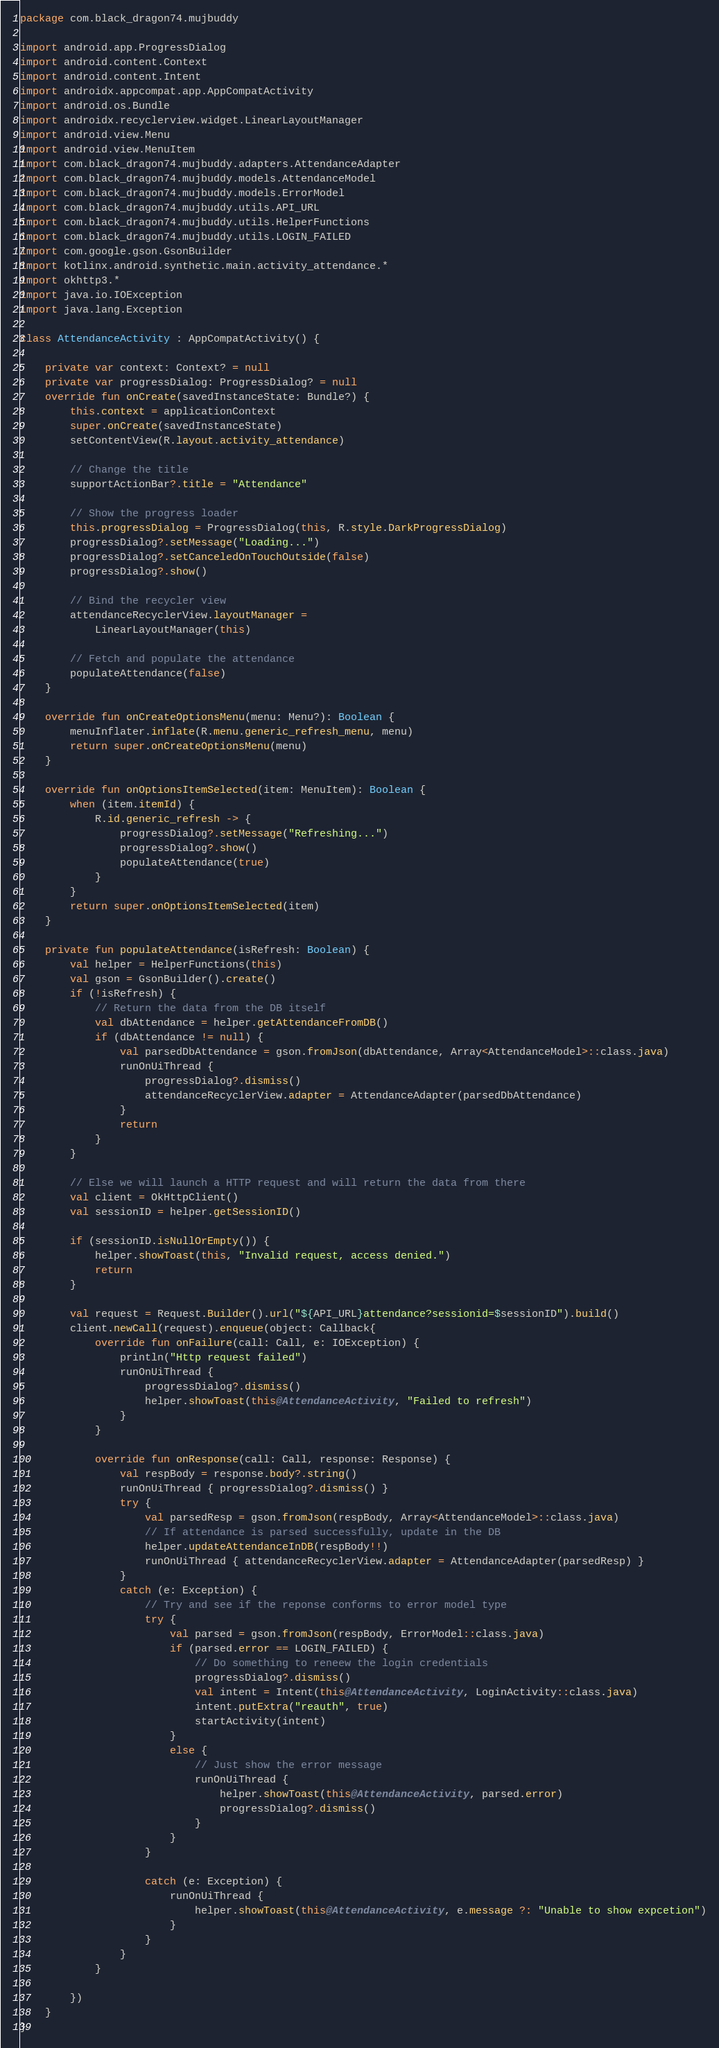<code> <loc_0><loc_0><loc_500><loc_500><_Kotlin_>package com.black_dragon74.mujbuddy

import android.app.ProgressDialog
import android.content.Context
import android.content.Intent
import androidx.appcompat.app.AppCompatActivity
import android.os.Bundle
import androidx.recyclerview.widget.LinearLayoutManager
import android.view.Menu
import android.view.MenuItem
import com.black_dragon74.mujbuddy.adapters.AttendanceAdapter
import com.black_dragon74.mujbuddy.models.AttendanceModel
import com.black_dragon74.mujbuddy.models.ErrorModel
import com.black_dragon74.mujbuddy.utils.API_URL
import com.black_dragon74.mujbuddy.utils.HelperFunctions
import com.black_dragon74.mujbuddy.utils.LOGIN_FAILED
import com.google.gson.GsonBuilder
import kotlinx.android.synthetic.main.activity_attendance.*
import okhttp3.*
import java.io.IOException
import java.lang.Exception

class AttendanceActivity : AppCompatActivity() {

    private var context: Context? = null
    private var progressDialog: ProgressDialog? = null
    override fun onCreate(savedInstanceState: Bundle?) {
        this.context = applicationContext
        super.onCreate(savedInstanceState)
        setContentView(R.layout.activity_attendance)

        // Change the title
        supportActionBar?.title = "Attendance"

        // Show the progress loader
        this.progressDialog = ProgressDialog(this, R.style.DarkProgressDialog)
        progressDialog?.setMessage("Loading...")
        progressDialog?.setCanceledOnTouchOutside(false)
        progressDialog?.show()

        // Bind the recycler view
        attendanceRecyclerView.layoutManager =
            LinearLayoutManager(this)

        // Fetch and populate the attendance
        populateAttendance(false)
    }

    override fun onCreateOptionsMenu(menu: Menu?): Boolean {
        menuInflater.inflate(R.menu.generic_refresh_menu, menu)
        return super.onCreateOptionsMenu(menu)
    }

    override fun onOptionsItemSelected(item: MenuItem): Boolean {
        when (item.itemId) {
            R.id.generic_refresh -> {
                progressDialog?.setMessage("Refreshing...")
                progressDialog?.show()
                populateAttendance(true)
            }
        }
        return super.onOptionsItemSelected(item)
    }

    private fun populateAttendance(isRefresh: Boolean) {
        val helper = HelperFunctions(this)
        val gson = GsonBuilder().create()
        if (!isRefresh) {
            // Return the data from the DB itself
            val dbAttendance = helper.getAttendanceFromDB()
            if (dbAttendance != null) {
                val parsedDbAttendance = gson.fromJson(dbAttendance, Array<AttendanceModel>::class.java)
                runOnUiThread {
                    progressDialog?.dismiss()
                    attendanceRecyclerView.adapter = AttendanceAdapter(parsedDbAttendance)
                }
                return
            }
        }

        // Else we will launch a HTTP request and will return the data from there
        val client = OkHttpClient()
        val sessionID = helper.getSessionID()

        if (sessionID.isNullOrEmpty()) {
            helper.showToast(this, "Invalid request, access denied.")
            return
        }

        val request = Request.Builder().url("${API_URL}attendance?sessionid=$sessionID").build()
        client.newCall(request).enqueue(object: Callback{
            override fun onFailure(call: Call, e: IOException) {
                println("Http request failed")
                runOnUiThread {
                    progressDialog?.dismiss()
                    helper.showToast(this@AttendanceActivity, "Failed to refresh")
                }
            }

            override fun onResponse(call: Call, response: Response) {
                val respBody = response.body?.string()
                runOnUiThread { progressDialog?.dismiss() }
                try {
                    val parsedResp = gson.fromJson(respBody, Array<AttendanceModel>::class.java)
                    // If attendance is parsed successfully, update in the DB
                    helper.updateAttendanceInDB(respBody!!)
                    runOnUiThread { attendanceRecyclerView.adapter = AttendanceAdapter(parsedResp) }
                }
                catch (e: Exception) {
                    // Try and see if the reponse conforms to error model type
                    try {
                        val parsed = gson.fromJson(respBody, ErrorModel::class.java)
                        if (parsed.error == LOGIN_FAILED) {
                            // Do something to reneew the login credentials
                            progressDialog?.dismiss()
                            val intent = Intent(this@AttendanceActivity, LoginActivity::class.java)
                            intent.putExtra("reauth", true)
                            startActivity(intent)
                        }
                        else {
                            // Just show the error message
                            runOnUiThread {
                                helper.showToast(this@AttendanceActivity, parsed.error)
                                progressDialog?.dismiss()
                            }
                        }
                    }

                    catch (e: Exception) {
                        runOnUiThread {
                            helper.showToast(this@AttendanceActivity, e.message ?: "Unable to show expcetion")
                        }
                    }
                }
            }

        })
    }
}
</code> 